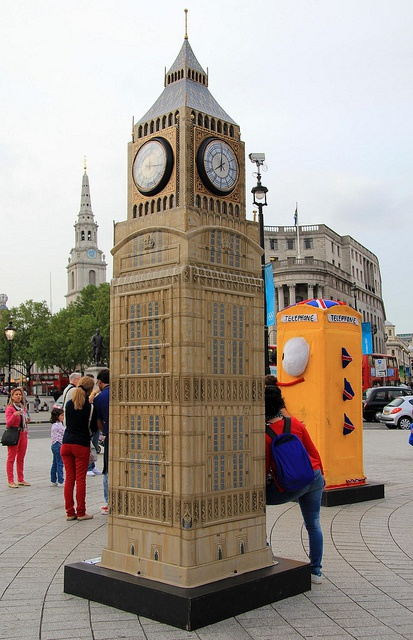Describe the objects in this image and their specific colors. I can see people in white, black, maroon, and brown tones, backpack in white, navy, black, darkblue, and maroon tones, people in white, brown, black, and maroon tones, clock in white, darkgray, gray, and black tones, and clock in white, lightgray, darkgray, and tan tones in this image. 